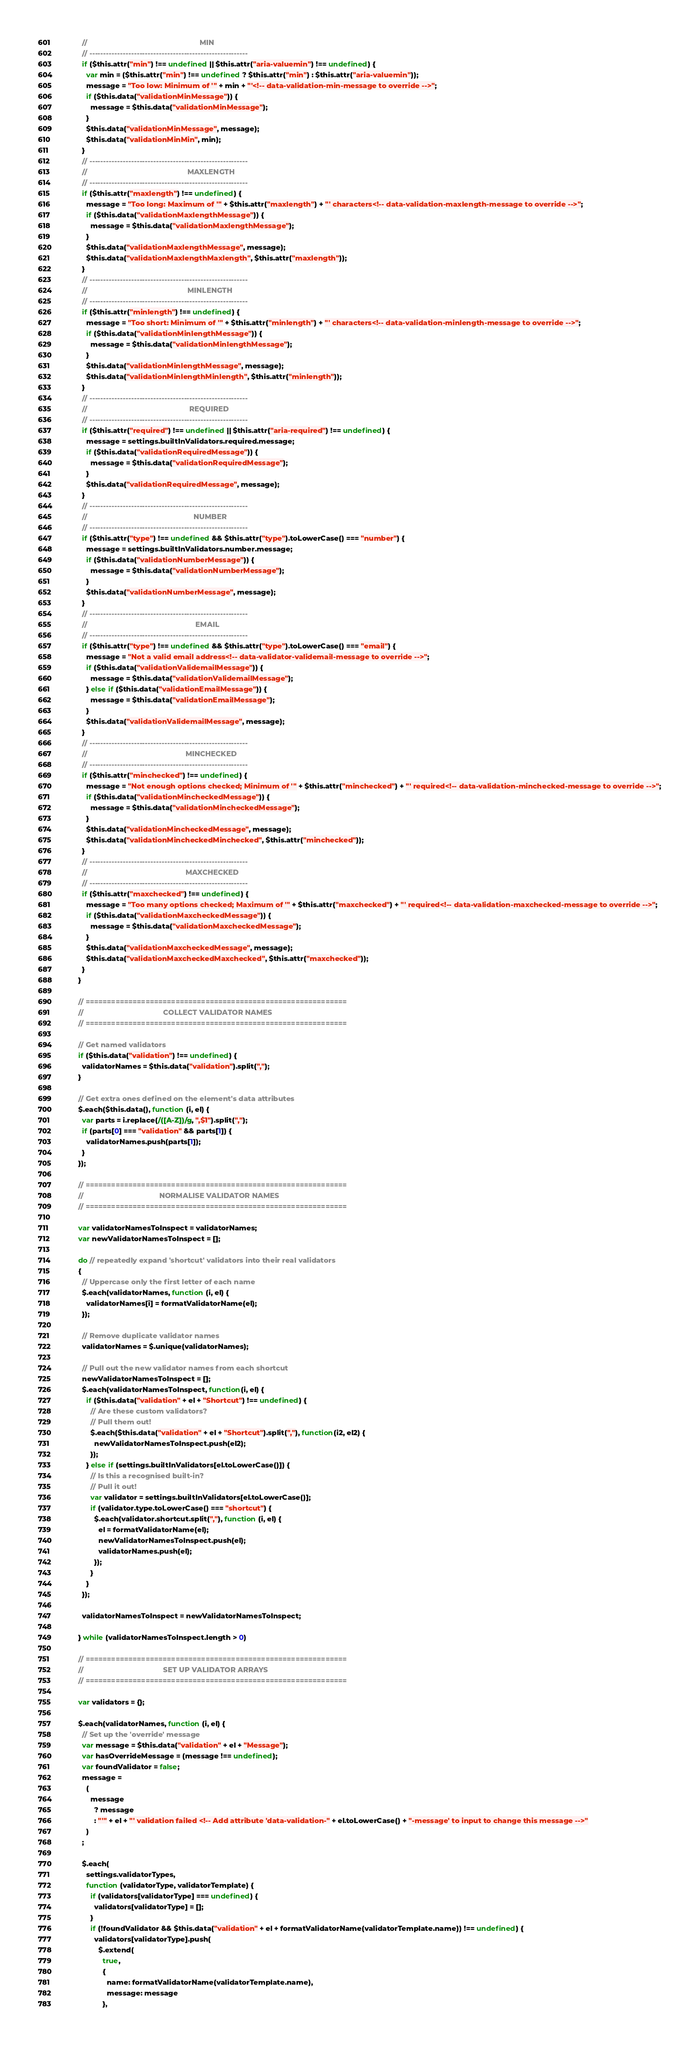Convert code to text. <code><loc_0><loc_0><loc_500><loc_500><_JavaScript_>            //                                                       MIN
            // ---------------------------------------------------------
            if ($this.attr("min") !== undefined || $this.attr("aria-valuemin") !== undefined) {
              var min = ($this.attr("min") !== undefined ? $this.attr("min") : $this.attr("aria-valuemin"));
              message = "Too low: Minimum of '" + min + "'<!-- data-validation-min-message to override -->";
              if ($this.data("validationMinMessage")) {
                message = $this.data("validationMinMessage");
              }
              $this.data("validationMinMessage", message);
              $this.data("validationMinMin", min);
            }
            // ---------------------------------------------------------
            //                                                 MAXLENGTH
            // ---------------------------------------------------------
            if ($this.attr("maxlength") !== undefined) {
              message = "Too long: Maximum of '" + $this.attr("maxlength") + "' characters<!-- data-validation-maxlength-message to override -->";
              if ($this.data("validationMaxlengthMessage")) {
                message = $this.data("validationMaxlengthMessage");
              }
              $this.data("validationMaxlengthMessage", message);
              $this.data("validationMaxlengthMaxlength", $this.attr("maxlength"));
            }
            // ---------------------------------------------------------
            //                                                 MINLENGTH
            // ---------------------------------------------------------
            if ($this.attr("minlength") !== undefined) {
              message = "Too short: Minimum of '" + $this.attr("minlength") + "' characters<!-- data-validation-minlength-message to override -->";
              if ($this.data("validationMinlengthMessage")) {
                message = $this.data("validationMinlengthMessage");
              }
              $this.data("validationMinlengthMessage", message);
              $this.data("validationMinlengthMinlength", $this.attr("minlength"));
            }
            // ---------------------------------------------------------
            //                                                  REQUIRED
            // ---------------------------------------------------------
            if ($this.attr("required") !== undefined || $this.attr("aria-required") !== undefined) {
              message = settings.builtInValidators.required.message;
              if ($this.data("validationRequiredMessage")) {
                message = $this.data("validationRequiredMessage");
              }
              $this.data("validationRequiredMessage", message);
            }
            // ---------------------------------------------------------
            //                                                    NUMBER
            // ---------------------------------------------------------
            if ($this.attr("type") !== undefined && $this.attr("type").toLowerCase() === "number") {
              message = settings.builtInValidators.number.message;
              if ($this.data("validationNumberMessage")) {
                message = $this.data("validationNumberMessage");
              }
              $this.data("validationNumberMessage", message);
            }
            // ---------------------------------------------------------
            //                                                     EMAIL
            // ---------------------------------------------------------
            if ($this.attr("type") !== undefined && $this.attr("type").toLowerCase() === "email") {
              message = "Not a valid email address<!-- data-validator-validemail-message to override -->";
              if ($this.data("validationValidemailMessage")) {
                message = $this.data("validationValidemailMessage");
              } else if ($this.data("validationEmailMessage")) {
                message = $this.data("validationEmailMessage");
              }
              $this.data("validationValidemailMessage", message);
            }
            // ---------------------------------------------------------
            //                                                MINCHECKED
            // ---------------------------------------------------------
            if ($this.attr("minchecked") !== undefined) {
              message = "Not enough options checked; Minimum of '" + $this.attr("minchecked") + "' required<!-- data-validation-minchecked-message to override -->";
              if ($this.data("validationMincheckedMessage")) {
                message = $this.data("validationMincheckedMessage");
              }
              $this.data("validationMincheckedMessage", message);
              $this.data("validationMincheckedMinchecked", $this.attr("minchecked"));
            }
            // ---------------------------------------------------------
            //                                                MAXCHECKED
            // ---------------------------------------------------------
            if ($this.attr("maxchecked") !== undefined) {
              message = "Too many options checked; Maximum of '" + $this.attr("maxchecked") + "' required<!-- data-validation-maxchecked-message to override -->";
              if ($this.data("validationMaxcheckedMessage")) {
                message = $this.data("validationMaxcheckedMessage");
              }
              $this.data("validationMaxcheckedMessage", message);
              $this.data("validationMaxcheckedMaxchecked", $this.attr("maxchecked"));
            }
          }

          // =============================================================
          //                                       COLLECT VALIDATOR NAMES
          // =============================================================

          // Get named validators
          if ($this.data("validation") !== undefined) {
            validatorNames = $this.data("validation").split(",");
          }

          // Get extra ones defined on the element's data attributes
          $.each($this.data(), function (i, el) {
            var parts = i.replace(/([A-Z])/g, ",$1").split(",");
            if (parts[0] === "validation" && parts[1]) {
              validatorNames.push(parts[1]);
            }
          });

          // =============================================================
          //                                     NORMALISE VALIDATOR NAMES
          // =============================================================

          var validatorNamesToInspect = validatorNames;
          var newValidatorNamesToInspect = [];

          do // repeatedly expand 'shortcut' validators into their real validators
          {
            // Uppercase only the first letter of each name
            $.each(validatorNames, function (i, el) {
              validatorNames[i] = formatValidatorName(el);
            });

            // Remove duplicate validator names
            validatorNames = $.unique(validatorNames);

            // Pull out the new validator names from each shortcut
            newValidatorNamesToInspect = [];
            $.each(validatorNamesToInspect, function(i, el) {
              if ($this.data("validation" + el + "Shortcut") !== undefined) {
                // Are these custom validators?
                // Pull them out!
                $.each($this.data("validation" + el + "Shortcut").split(","), function(i2, el2) {
                  newValidatorNamesToInspect.push(el2);
                });
              } else if (settings.builtInValidators[el.toLowerCase()]) {
                // Is this a recognised built-in?
                // Pull it out!
                var validator = settings.builtInValidators[el.toLowerCase()];
                if (validator.type.toLowerCase() === "shortcut") {
                  $.each(validator.shortcut.split(","), function (i, el) {
                    el = formatValidatorName(el);
                    newValidatorNamesToInspect.push(el);
                    validatorNames.push(el);
                  });
                }
              }
            });

            validatorNamesToInspect = newValidatorNamesToInspect;

          } while (validatorNamesToInspect.length > 0)

          // =============================================================
          //                                       SET UP VALIDATOR ARRAYS
          // =============================================================

          var validators = {};

          $.each(validatorNames, function (i, el) {
            // Set up the 'override' message
            var message = $this.data("validation" + el + "Message");
            var hasOverrideMessage = (message !== undefined);
            var foundValidator = false;
            message =
              (
                message
                  ? message
                  : "'" + el + "' validation failed <!-- Add attribute 'data-validation-" + el.toLowerCase() + "-message' to input to change this message -->"
              )
            ;

            $.each(
              settings.validatorTypes,
              function (validatorType, validatorTemplate) {
                if (validators[validatorType] === undefined) {
                  validators[validatorType] = [];
                }
                if (!foundValidator && $this.data("validation" + el + formatValidatorName(validatorTemplate.name)) !== undefined) {
                  validators[validatorType].push(
                    $.extend(
                      true,
                      {
                        name: formatValidatorName(validatorTemplate.name),
                        message: message
                      },</code> 